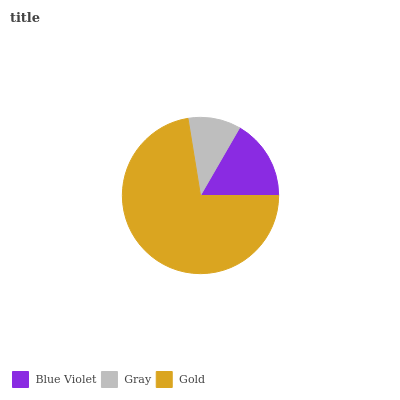Is Gray the minimum?
Answer yes or no. Yes. Is Gold the maximum?
Answer yes or no. Yes. Is Gold the minimum?
Answer yes or no. No. Is Gray the maximum?
Answer yes or no. No. Is Gold greater than Gray?
Answer yes or no. Yes. Is Gray less than Gold?
Answer yes or no. Yes. Is Gray greater than Gold?
Answer yes or no. No. Is Gold less than Gray?
Answer yes or no. No. Is Blue Violet the high median?
Answer yes or no. Yes. Is Blue Violet the low median?
Answer yes or no. Yes. Is Gold the high median?
Answer yes or no. No. Is Gold the low median?
Answer yes or no. No. 